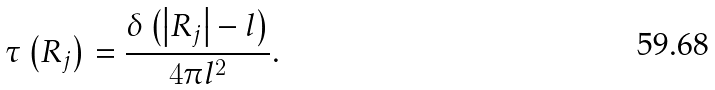Convert formula to latex. <formula><loc_0><loc_0><loc_500><loc_500>\tau \left ( R _ { j } \right ) = \frac { \delta \left ( \left | R _ { j } \right | - l \right ) } { 4 \pi l ^ { 2 } } .</formula> 